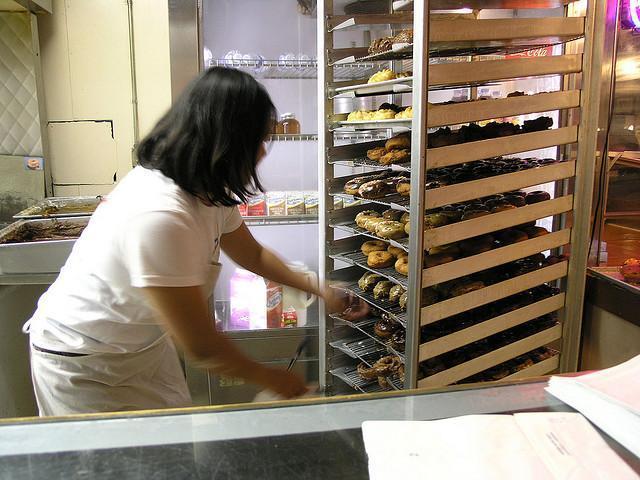How many people are on the couch are men?
Give a very brief answer. 0. 